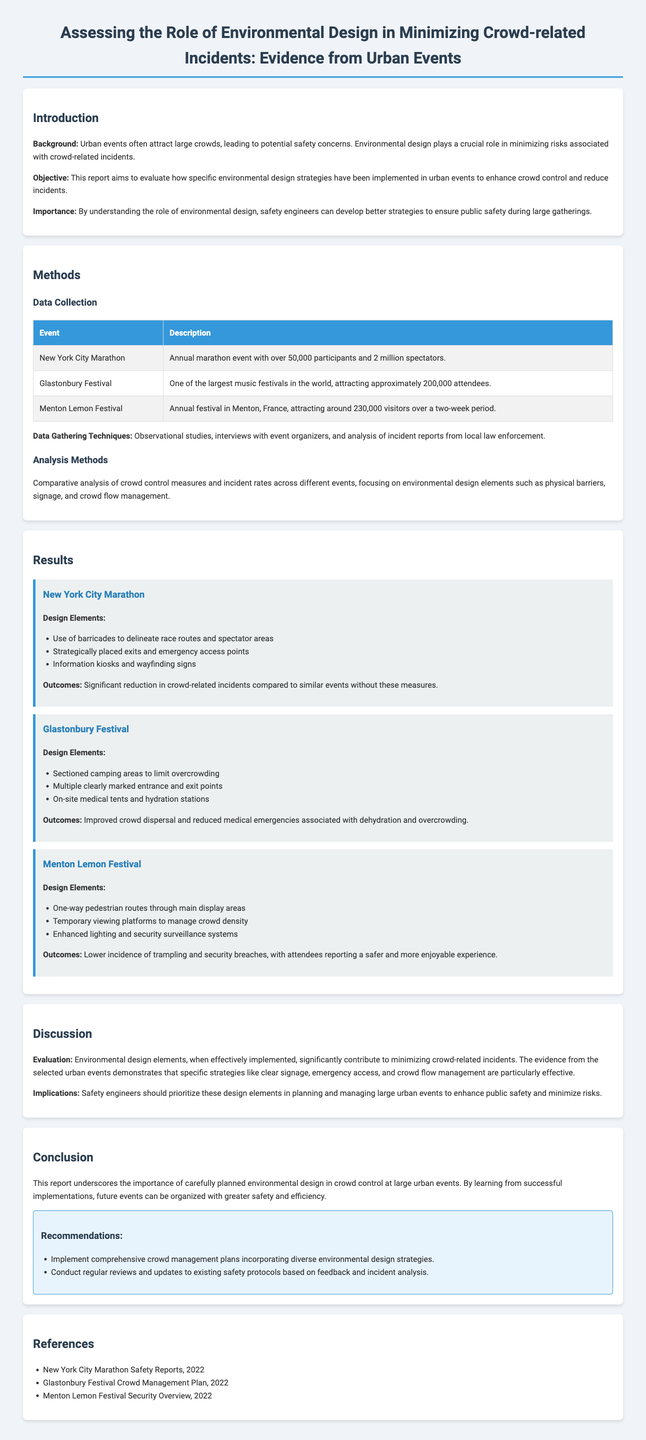What is the objective of the report? The report aims to evaluate how specific environmental design strategies have been implemented in urban events to enhance crowd control and reduce incidents.
Answer: To evaluate environmental design strategies What event attracted approximately 200,000 attendees? The event mentioned in the document that attracted around 200,000 attendees is the Glastonbury Festival.
Answer: Glastonbury Festival How did the New York City Marathon enhance crowd safety? The New York City Marathon used barricades, strategically placed exits, and information kiosks to enhance crowd safety.
Answer: Barricades, exits, kiosks What was one key outcome of the Menton Lemon Festival's design elements? One key outcome was lower incidence of trampling and security breaches, leading to a safer experience for attendees.
Answer: Lower incidence of trampling and security breaches What does the report emphasize about environmental design? The report emphasizes that carefully planned environmental design significantly contributes to minimizing crowd-related incidents.
Answer: Minimizing crowd-related incidents What is one of the recommendations made in the report? One recommendation is to implement comprehensive crowd management plans incorporating diverse environmental design strategies.
Answer: Implement comprehensive crowd management plans 